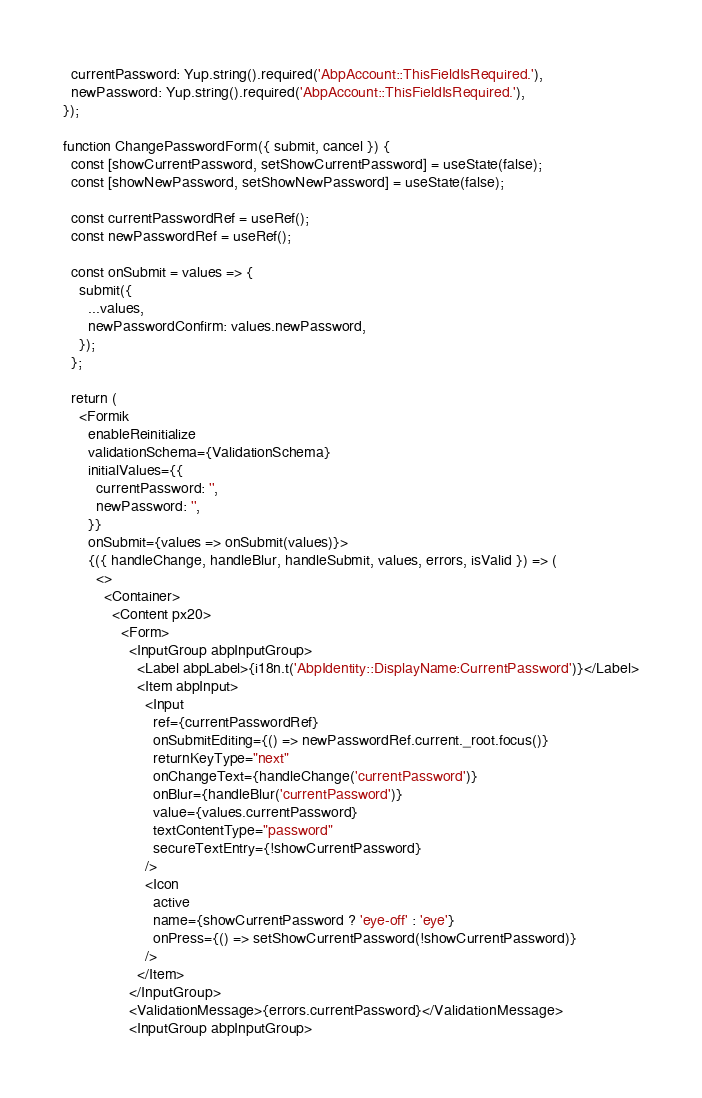<code> <loc_0><loc_0><loc_500><loc_500><_JavaScript_>  currentPassword: Yup.string().required('AbpAccount::ThisFieldIsRequired.'),
  newPassword: Yup.string().required('AbpAccount::ThisFieldIsRequired.'),
});

function ChangePasswordForm({ submit, cancel }) {
  const [showCurrentPassword, setShowCurrentPassword] = useState(false);
  const [showNewPassword, setShowNewPassword] = useState(false);

  const currentPasswordRef = useRef();
  const newPasswordRef = useRef();

  const onSubmit = values => {
    submit({
      ...values,
      newPasswordConfirm: values.newPassword,
    });
  };

  return (
    <Formik
      enableReinitialize
      validationSchema={ValidationSchema}
      initialValues={{
        currentPassword: '',
        newPassword: '',
      }}
      onSubmit={values => onSubmit(values)}>
      {({ handleChange, handleBlur, handleSubmit, values, errors, isValid }) => (
        <>
          <Container>
            <Content px20>
              <Form>
                <InputGroup abpInputGroup>
                  <Label abpLabel>{i18n.t('AbpIdentity::DisplayName:CurrentPassword')}</Label>
                  <Item abpInput>
                    <Input
                      ref={currentPasswordRef}
                      onSubmitEditing={() => newPasswordRef.current._root.focus()}
                      returnKeyType="next"
                      onChangeText={handleChange('currentPassword')}
                      onBlur={handleBlur('currentPassword')}
                      value={values.currentPassword}
                      textContentType="password"
                      secureTextEntry={!showCurrentPassword}
                    />
                    <Icon
                      active
                      name={showCurrentPassword ? 'eye-off' : 'eye'}
                      onPress={() => setShowCurrentPassword(!showCurrentPassword)}
                    />
                  </Item>
                </InputGroup>
                <ValidationMessage>{errors.currentPassword}</ValidationMessage>
                <InputGroup abpInputGroup></code> 